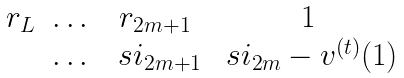Convert formula to latex. <formula><loc_0><loc_0><loc_500><loc_500>\begin{matrix} r _ { L } & \dots & r _ { 2 m + 1 } & 1 \\ & \dots & \ s i _ { 2 m + 1 } & \ s i _ { 2 m } - v ^ { ( t ) } ( 1 ) \end{matrix}</formula> 